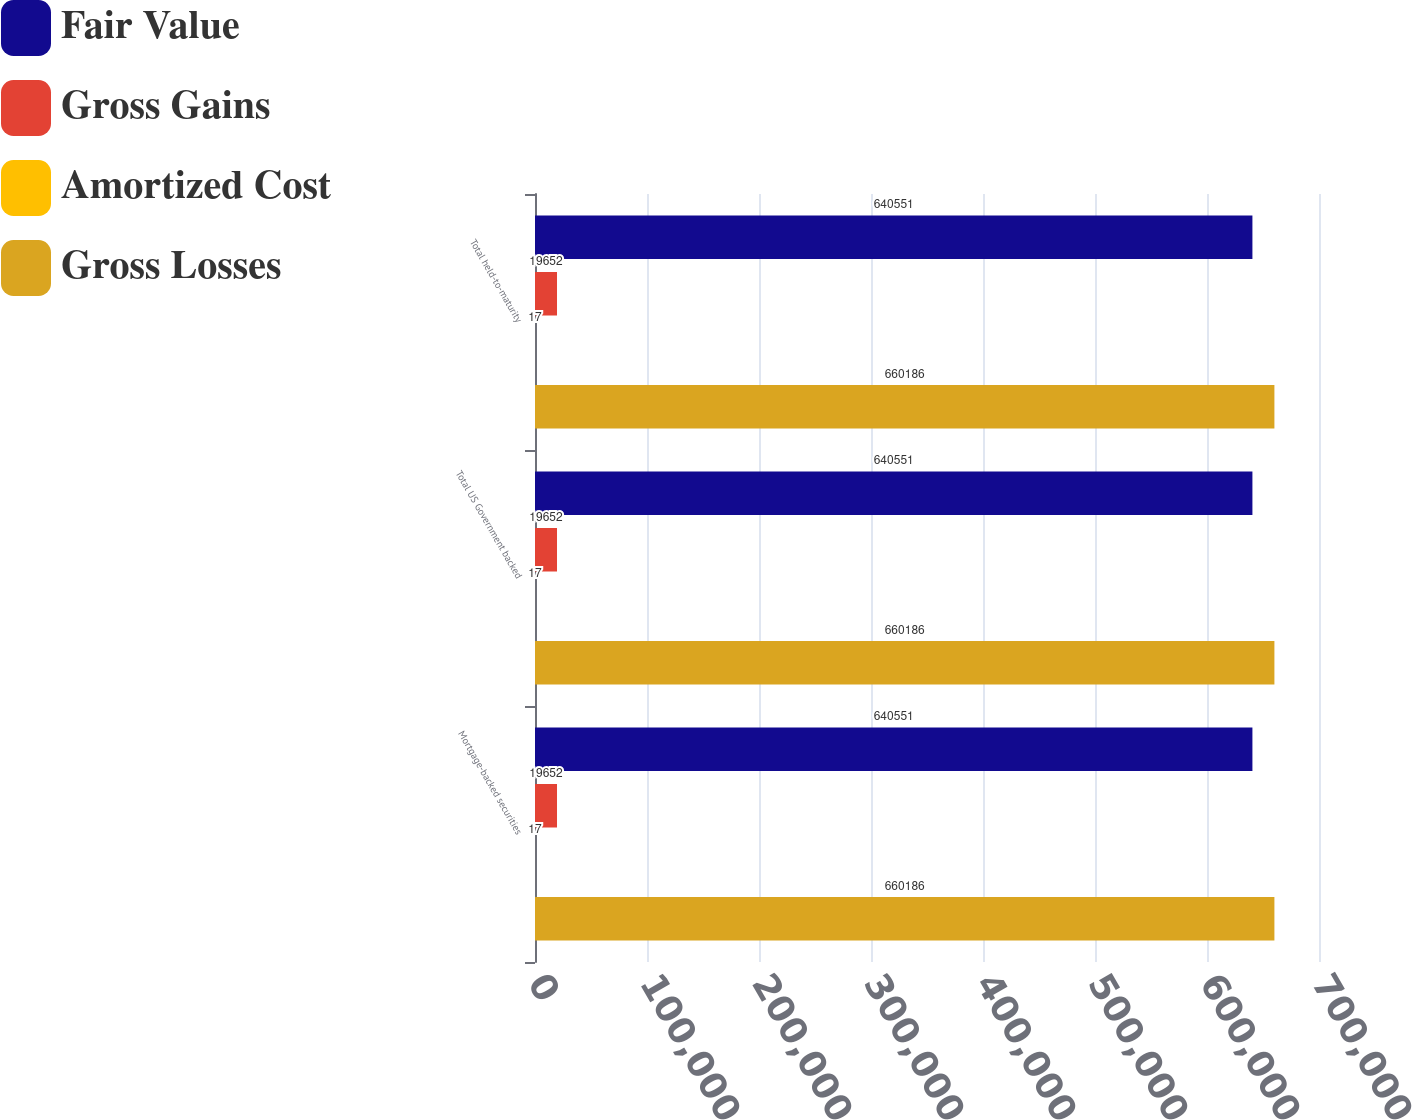Convert chart to OTSL. <chart><loc_0><loc_0><loc_500><loc_500><stacked_bar_chart><ecel><fcel>Mortgage-backed securities<fcel>Total US Government backed<fcel>Total held-to-maturity<nl><fcel>Fair Value<fcel>640551<fcel>640551<fcel>640551<nl><fcel>Gross Gains<fcel>19652<fcel>19652<fcel>19652<nl><fcel>Amortized Cost<fcel>17<fcel>17<fcel>17<nl><fcel>Gross Losses<fcel>660186<fcel>660186<fcel>660186<nl></chart> 